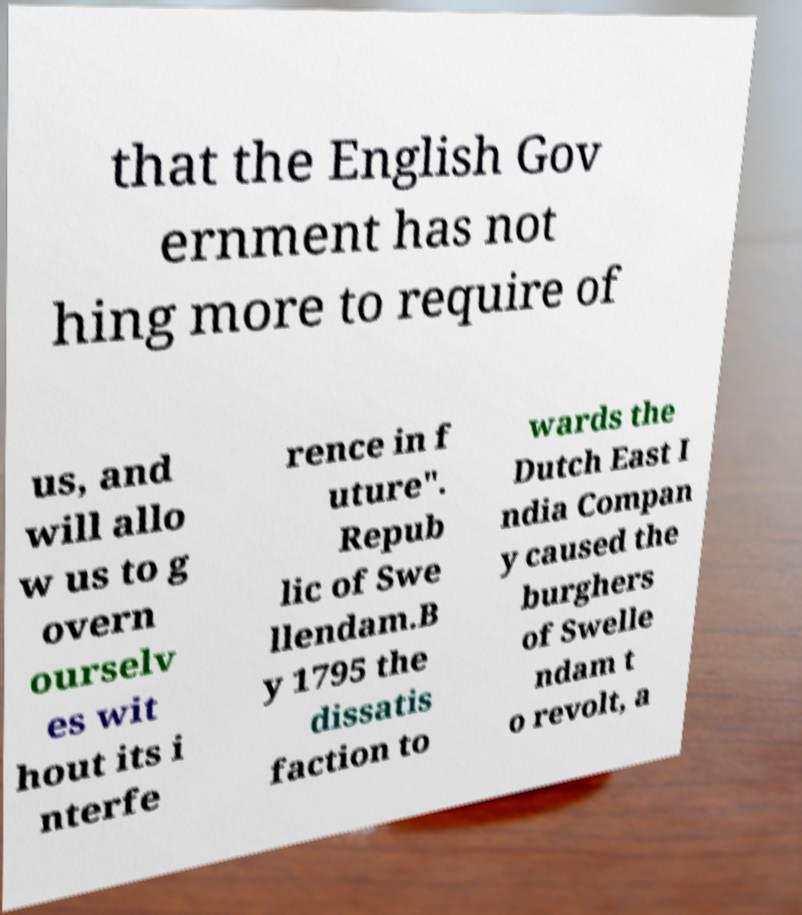I need the written content from this picture converted into text. Can you do that? that the English Gov ernment has not hing more to require of us, and will allo w us to g overn ourselv es wit hout its i nterfe rence in f uture". Repub lic of Swe llendam.B y 1795 the dissatis faction to wards the Dutch East I ndia Compan y caused the burghers of Swelle ndam t o revolt, a 